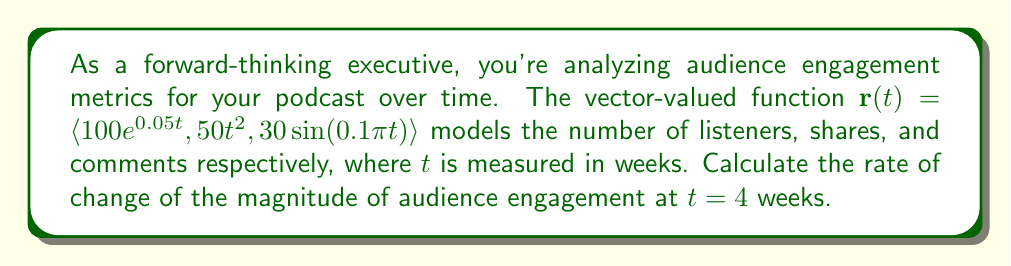Provide a solution to this math problem. To solve this problem, we'll follow these steps:

1) The magnitude of the vector-valued function is given by:

   $$|\mathbf{r}(t)| = \sqrt{(100e^{0.05t})^2 + (50t^2)^2 + (30\sin(0.1\pi t))^2}$$

2) To find the rate of change of the magnitude, we need to differentiate this with respect to $t$:

   $$\frac{d}{dt}|\mathbf{r}(t)| = \frac{1}{2|\mathbf{r}(t)|} \cdot \frac{d}{dt}[(100e^{0.05t})^2 + (50t^2)^2 + (30\sin(0.1\pi t))^2]$$

3) Let's differentiate each term inside the square root:

   $$\frac{d}{dt}(100e^{0.05t})^2 = 2(100e^{0.05t})(100 \cdot 0.05e^{0.05t}) = 1000e^{0.1t}$$
   
   $$\frac{d}{dt}(50t^2)^2 = 2(50t^2)(100t) = 10000t^3$$
   
   $$\frac{d}{dt}(30\sin(0.1\pi t))^2 = 2(30\sin(0.1\pi t))(30 \cdot 0.1\pi \cos(0.1\pi t)) = 180\pi \sin(0.1\pi t)\cos(0.1\pi t)$$

4) Substituting these back into our equation:

   $$\frac{d}{dt}|\mathbf{r}(t)| = \frac{1000e^{0.1t} + 10000t^3 + 180\pi \sin(0.1\pi t)\cos(0.1\pi t)}{2\sqrt{(100e^{0.05t})^2 + (50t^2)^2 + (30\sin(0.1\pi t))^2}}$$

5) Now we evaluate this at $t = 4$:

   $$\frac{d}{dt}|\mathbf{r}(4)| = \frac{1000e^{0.4} + 10000(4^3) + 180\pi \sin(0.4\pi)\cos(0.4\pi)}{2\sqrt{(100e^{0.2})^2 + (50 \cdot 4^2)^2 + (30\sin(0.4\pi))^2}}$$

6) Calculating this numerically:

   $$\frac{d}{dt}|\mathbf{r}(4)| \approx 404.26$$
Answer: The rate of change of the magnitude of audience engagement at $t = 4$ weeks is approximately 404.26 units per week. 